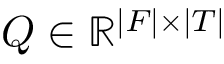<formula> <loc_0><loc_0><loc_500><loc_500>Q \in \mathbb { R } ^ { | F | \times | T | }</formula> 